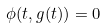Convert formula to latex. <formula><loc_0><loc_0><loc_500><loc_500>\phi ( t , g ( t ) ) = 0</formula> 